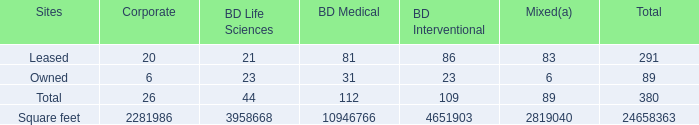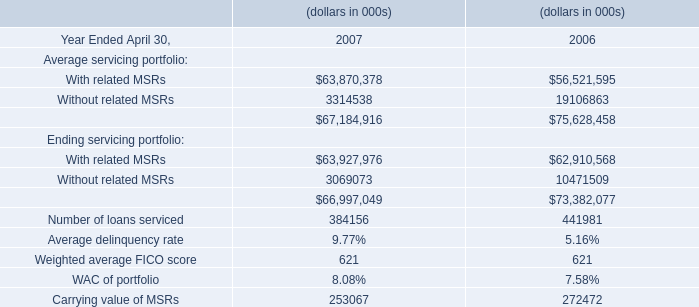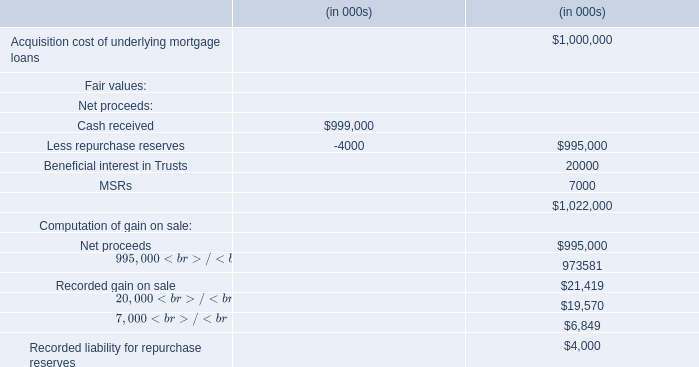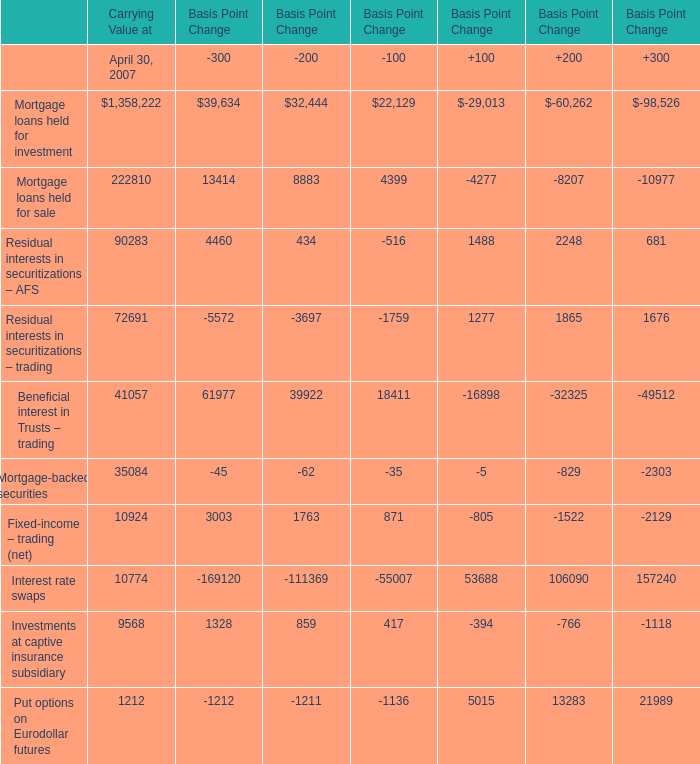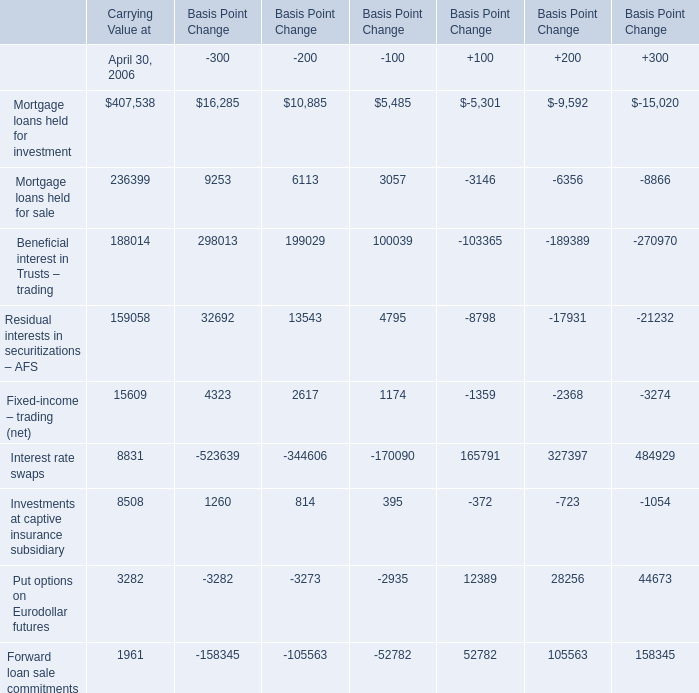In the section with largest amount of Residual interests in securitizations – AFS, what's the sum of Carrying Value at April 30, 2006? 
Computations: ((((((((407538 + 236399) + 188014) + 159058) + 15609) + 8831) + 8508) + 3282) + 1961)
Answer: 1029200.0. 